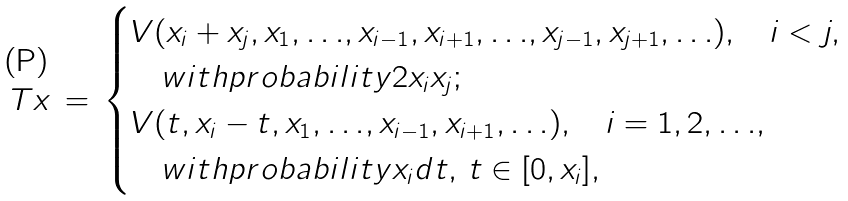<formula> <loc_0><loc_0><loc_500><loc_500>T x \, = \, \begin{cases} V ( x _ { i } + x _ { j } , x _ { 1 } , { \dots } , x _ { i - 1 } , x _ { i + 1 } , { \dots } , x _ { j - 1 } , x _ { j + 1 } , { \dots } ) , \quad i < j , \\ \quad w i t h p r o b a b i l i t y 2 x _ { i } x _ { j } ; \\ V ( t , x _ { i } - t , x _ { 1 } , { \dots } , x _ { i - 1 } , x _ { i + 1 } , { \dots } ) , \quad i = 1 , 2 , { \dots } , \\ \quad w i t h p r o b a b i l i t y x _ { i } d t , \, t \in [ 0 , x _ { i } ] , \end{cases}</formula> 